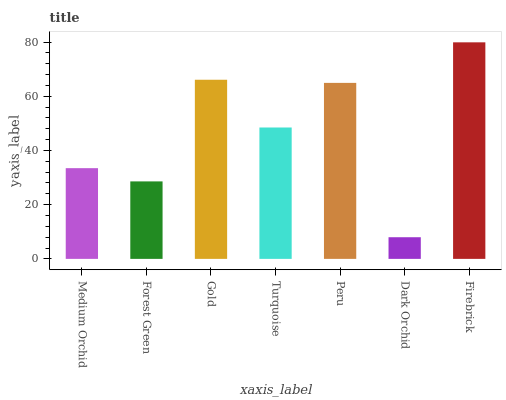Is Dark Orchid the minimum?
Answer yes or no. Yes. Is Firebrick the maximum?
Answer yes or no. Yes. Is Forest Green the minimum?
Answer yes or no. No. Is Forest Green the maximum?
Answer yes or no. No. Is Medium Orchid greater than Forest Green?
Answer yes or no. Yes. Is Forest Green less than Medium Orchid?
Answer yes or no. Yes. Is Forest Green greater than Medium Orchid?
Answer yes or no. No. Is Medium Orchid less than Forest Green?
Answer yes or no. No. Is Turquoise the high median?
Answer yes or no. Yes. Is Turquoise the low median?
Answer yes or no. Yes. Is Gold the high median?
Answer yes or no. No. Is Firebrick the low median?
Answer yes or no. No. 